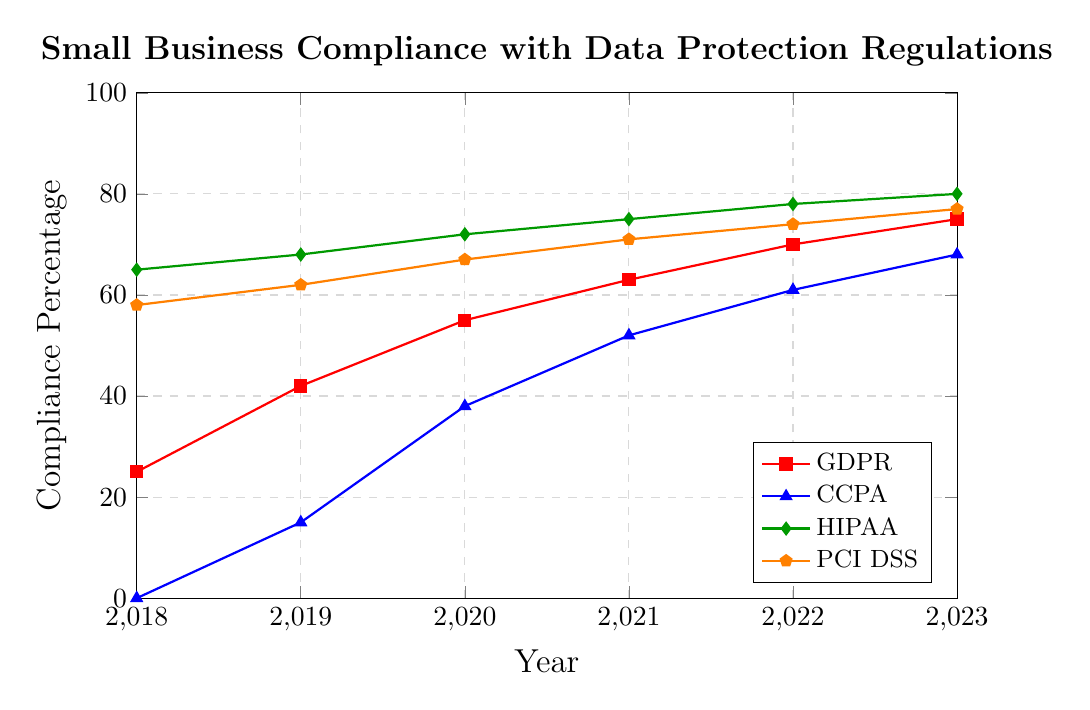What was the compliance percentage for GDPR in 2018 and 2023? Look at the values for the GDPR line in the years 2018 and 2023. The compliance percentages were 25% and 75%, respectively.
Answer: 25% in 2018, 75% in 2023 Has the HIPAA compliance percentage increased more or less steadily than the PCI DSS compliance percentage over the years? HIPAA started at 65% in 2018 and increased incrementally to 80% in 2023. PCI DSS started at 58% in 2018 and increased steadily to 77% in 2023. By comparing these trends, both have shown a steady increase, but HIPAA started higher and finished higher.
Answer: Both increased steadily What is the difference in compliance percentage between GDPR and CCPA in 2022? The compliance percentages for GDPR and CCPA in 2022 are 70% and 61%, respectively. Their difference is calculated as 70% - 61% = 9%.
Answer: 9% Among GDPR, CCPA, HIPAA, and PCI DSS, which regulation showed the highest compliance percentage increase from 2018 to 2023? Calculate the increase for each regulation from 2018 to 2023: GDPR (75% - 25% = 50%), CCPA (68% - 0% = 68%), HIPAA (80% - 65% = 15%), and PCI DSS (77% - 58% = 19%). CCPA had the highest increase at 68%.
Answer: CCPA In which year did CCPA compliance exceed 50%? By examining the CCPA trend line, the compliance percentage exceeded 50% in the year 2021.
Answer: 2021 What was the average compliance percentage of PCI DSS from 2018 to 2023? The PCI DSS percentages from 2018 to 2023 are 58, 62, 67, 71, 74, and 77. Calculate the average: (58 + 62 + 67 + 71 + 74 + 77)/6 = 409/6 ≈ 68.17%.
Answer: 68.17% How does the compliance percentage of HIPAA in 2020 compare to that of CCPA in the same year? In 2020, HIPAA's compliance percentage was 72%, while CCPA's compliance percentage was 38%. HIPAA had a higher compliance percentage than CCPA in 2020.
Answer: HIPAA > CCPA Which regulation had the smallest increase in compliance percentage from 2020 to 2023? Calculate the increase for each regulation from 2020 to 2023: GDPR (75% - 55% = 20%), CCPA (68% - 38% = 30%), HIPAA (80% - 72% = 8%), and PCI DSS (77% - 67% = 10%). HIPAA had the smallest increase at 8%.
Answer: HIPAA What year showed the highest compliance percentage for GDPR? The year with the highest compliance percentage for GDPR is 2023, with a compliance percentage of 75%.
Answer: 2023 